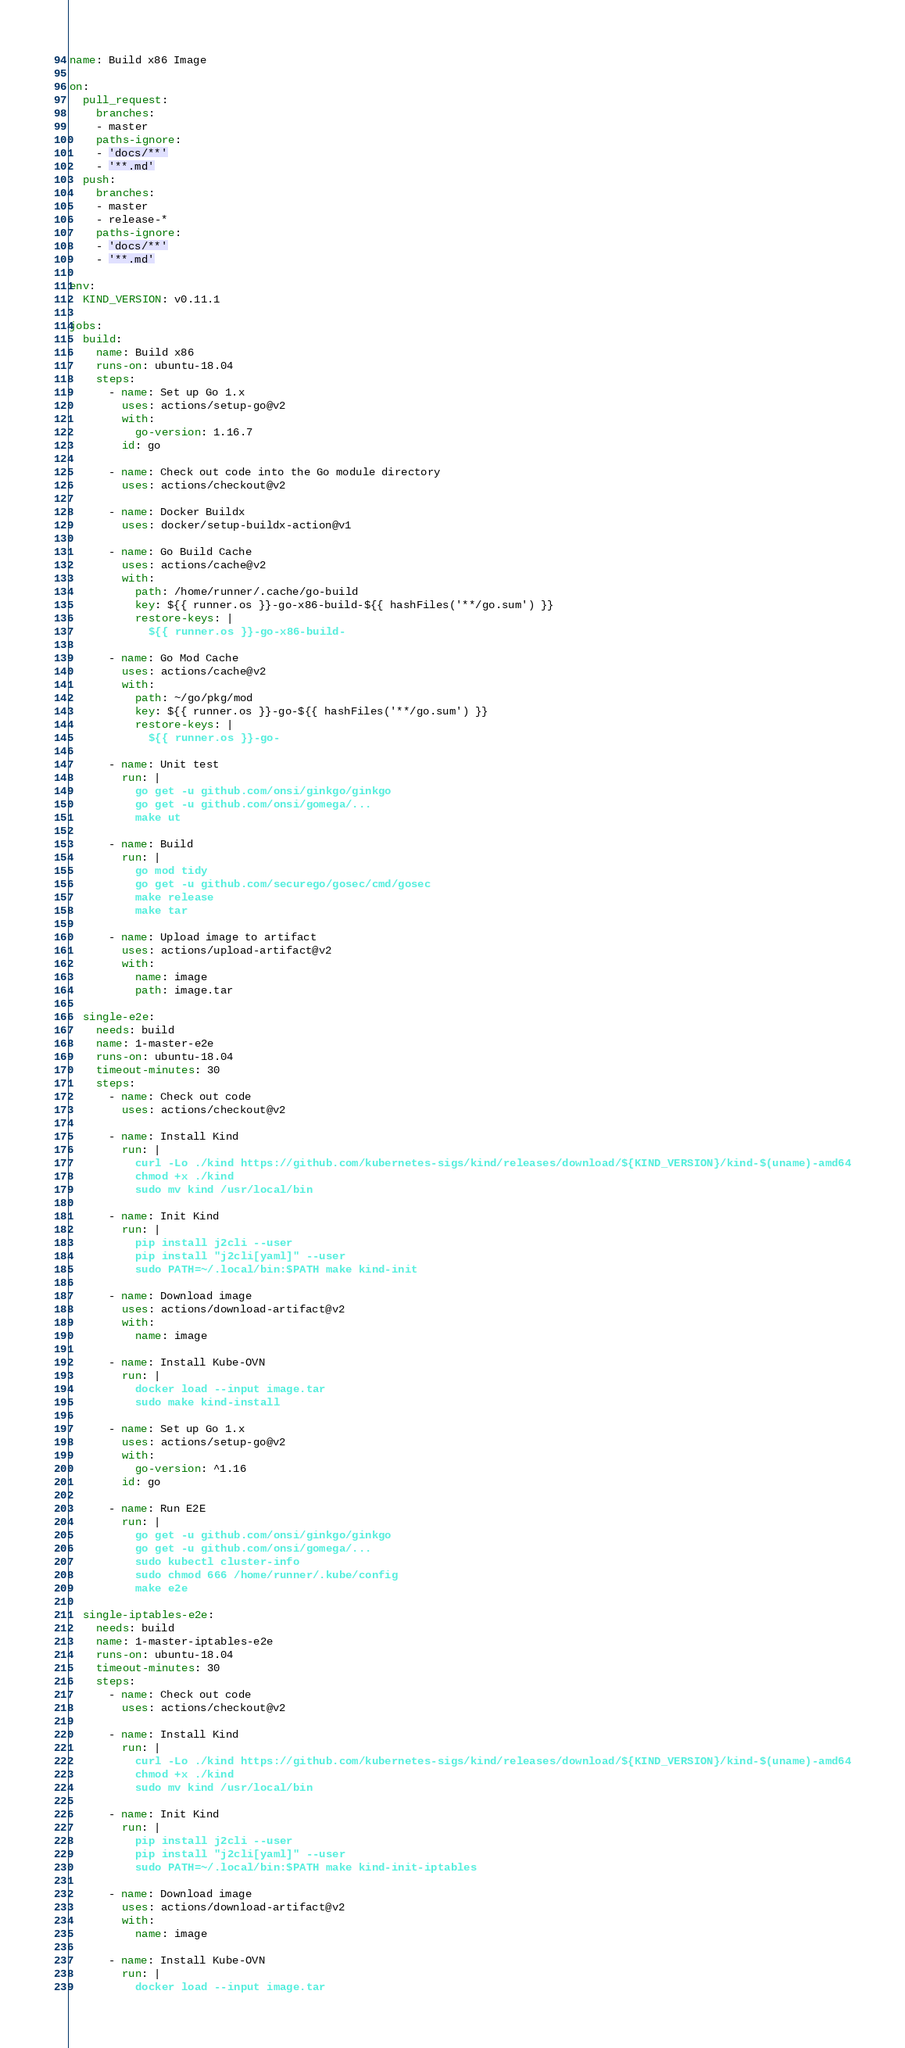<code> <loc_0><loc_0><loc_500><loc_500><_YAML_>name: Build x86 Image

on:
  pull_request:
    branches:
    - master
    paths-ignore:
    - 'docs/**'
    - '**.md'
  push:
    branches:
    - master
    - release-*
    paths-ignore:
    - 'docs/**'
    - '**.md'

env:
  KIND_VERSION: v0.11.1

jobs:
  build:
    name: Build x86
    runs-on: ubuntu-18.04
    steps:
      - name: Set up Go 1.x
        uses: actions/setup-go@v2
        with:
          go-version: 1.16.7
        id: go

      - name: Check out code into the Go module directory
        uses: actions/checkout@v2

      - name: Docker Buildx
        uses: docker/setup-buildx-action@v1

      - name: Go Build Cache
        uses: actions/cache@v2
        with:
          path: /home/runner/.cache/go-build
          key: ${{ runner.os }}-go-x86-build-${{ hashFiles('**/go.sum') }}
          restore-keys: |
            ${{ runner.os }}-go-x86-build-

      - name: Go Mod Cache
        uses: actions/cache@v2
        with:
          path: ~/go/pkg/mod
          key: ${{ runner.os }}-go-${{ hashFiles('**/go.sum') }}
          restore-keys: |
            ${{ runner.os }}-go-

      - name: Unit test
        run: |
          go get -u github.com/onsi/ginkgo/ginkgo
          go get -u github.com/onsi/gomega/...
          make ut

      - name: Build
        run: |
          go mod tidy
          go get -u github.com/securego/gosec/cmd/gosec
          make release
          make tar

      - name: Upload image to artifact
        uses: actions/upload-artifact@v2
        with:
          name: image
          path: image.tar

  single-e2e:
    needs: build
    name: 1-master-e2e
    runs-on: ubuntu-18.04
    timeout-minutes: 30
    steps:
      - name: Check out code
        uses: actions/checkout@v2

      - name: Install Kind
        run: |
          curl -Lo ./kind https://github.com/kubernetes-sigs/kind/releases/download/${KIND_VERSION}/kind-$(uname)-amd64
          chmod +x ./kind
          sudo mv kind /usr/local/bin

      - name: Init Kind
        run: |
          pip install j2cli --user
          pip install "j2cli[yaml]" --user
          sudo PATH=~/.local/bin:$PATH make kind-init

      - name: Download image
        uses: actions/download-artifact@v2
        with:
          name: image

      - name: Install Kube-OVN
        run: |
          docker load --input image.tar
          sudo make kind-install

      - name: Set up Go 1.x
        uses: actions/setup-go@v2
        with:
          go-version: ^1.16
        id: go

      - name: Run E2E
        run: |
          go get -u github.com/onsi/ginkgo/ginkgo
          go get -u github.com/onsi/gomega/...
          sudo kubectl cluster-info
          sudo chmod 666 /home/runner/.kube/config
          make e2e

  single-iptables-e2e:
    needs: build
    name: 1-master-iptables-e2e
    runs-on: ubuntu-18.04
    timeout-minutes: 30
    steps:
      - name: Check out code
        uses: actions/checkout@v2

      - name: Install Kind
        run: |
          curl -Lo ./kind https://github.com/kubernetes-sigs/kind/releases/download/${KIND_VERSION}/kind-$(uname)-amd64
          chmod +x ./kind
          sudo mv kind /usr/local/bin

      - name: Init Kind
        run: |
          pip install j2cli --user
          pip install "j2cli[yaml]" --user
          sudo PATH=~/.local/bin:$PATH make kind-init-iptables

      - name: Download image
        uses: actions/download-artifact@v2
        with:
          name: image

      - name: Install Kube-OVN
        run: |
          docker load --input image.tar</code> 